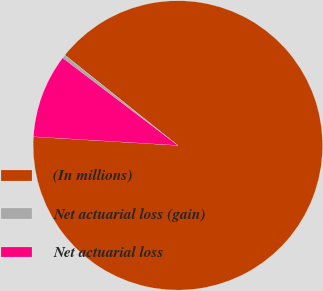Convert chart to OTSL. <chart><loc_0><loc_0><loc_500><loc_500><pie_chart><fcel>(In millions)<fcel>Net actuarial loss (gain)<fcel>Net actuarial loss<nl><fcel>90.21%<fcel>0.4%<fcel>9.38%<nl></chart> 